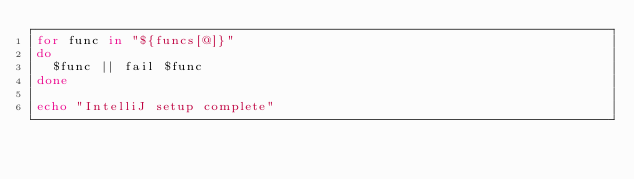<code> <loc_0><loc_0><loc_500><loc_500><_Bash_>for func in "${funcs[@]}"
do
	$func || fail $func
done

echo "IntelliJ setup complete"
</code> 